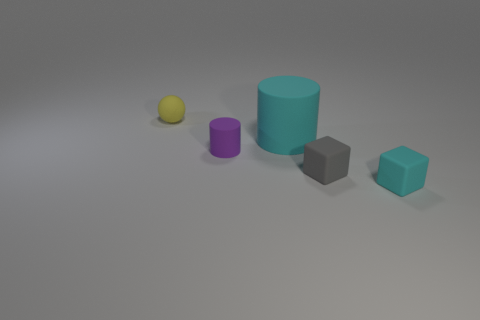Add 3 purple things. How many objects exist? 8 Subtract all cubes. How many objects are left? 3 Subtract all small gray objects. Subtract all large blue cylinders. How many objects are left? 4 Add 4 yellow rubber objects. How many yellow rubber objects are left? 5 Add 1 yellow things. How many yellow things exist? 2 Subtract 0 yellow cylinders. How many objects are left? 5 